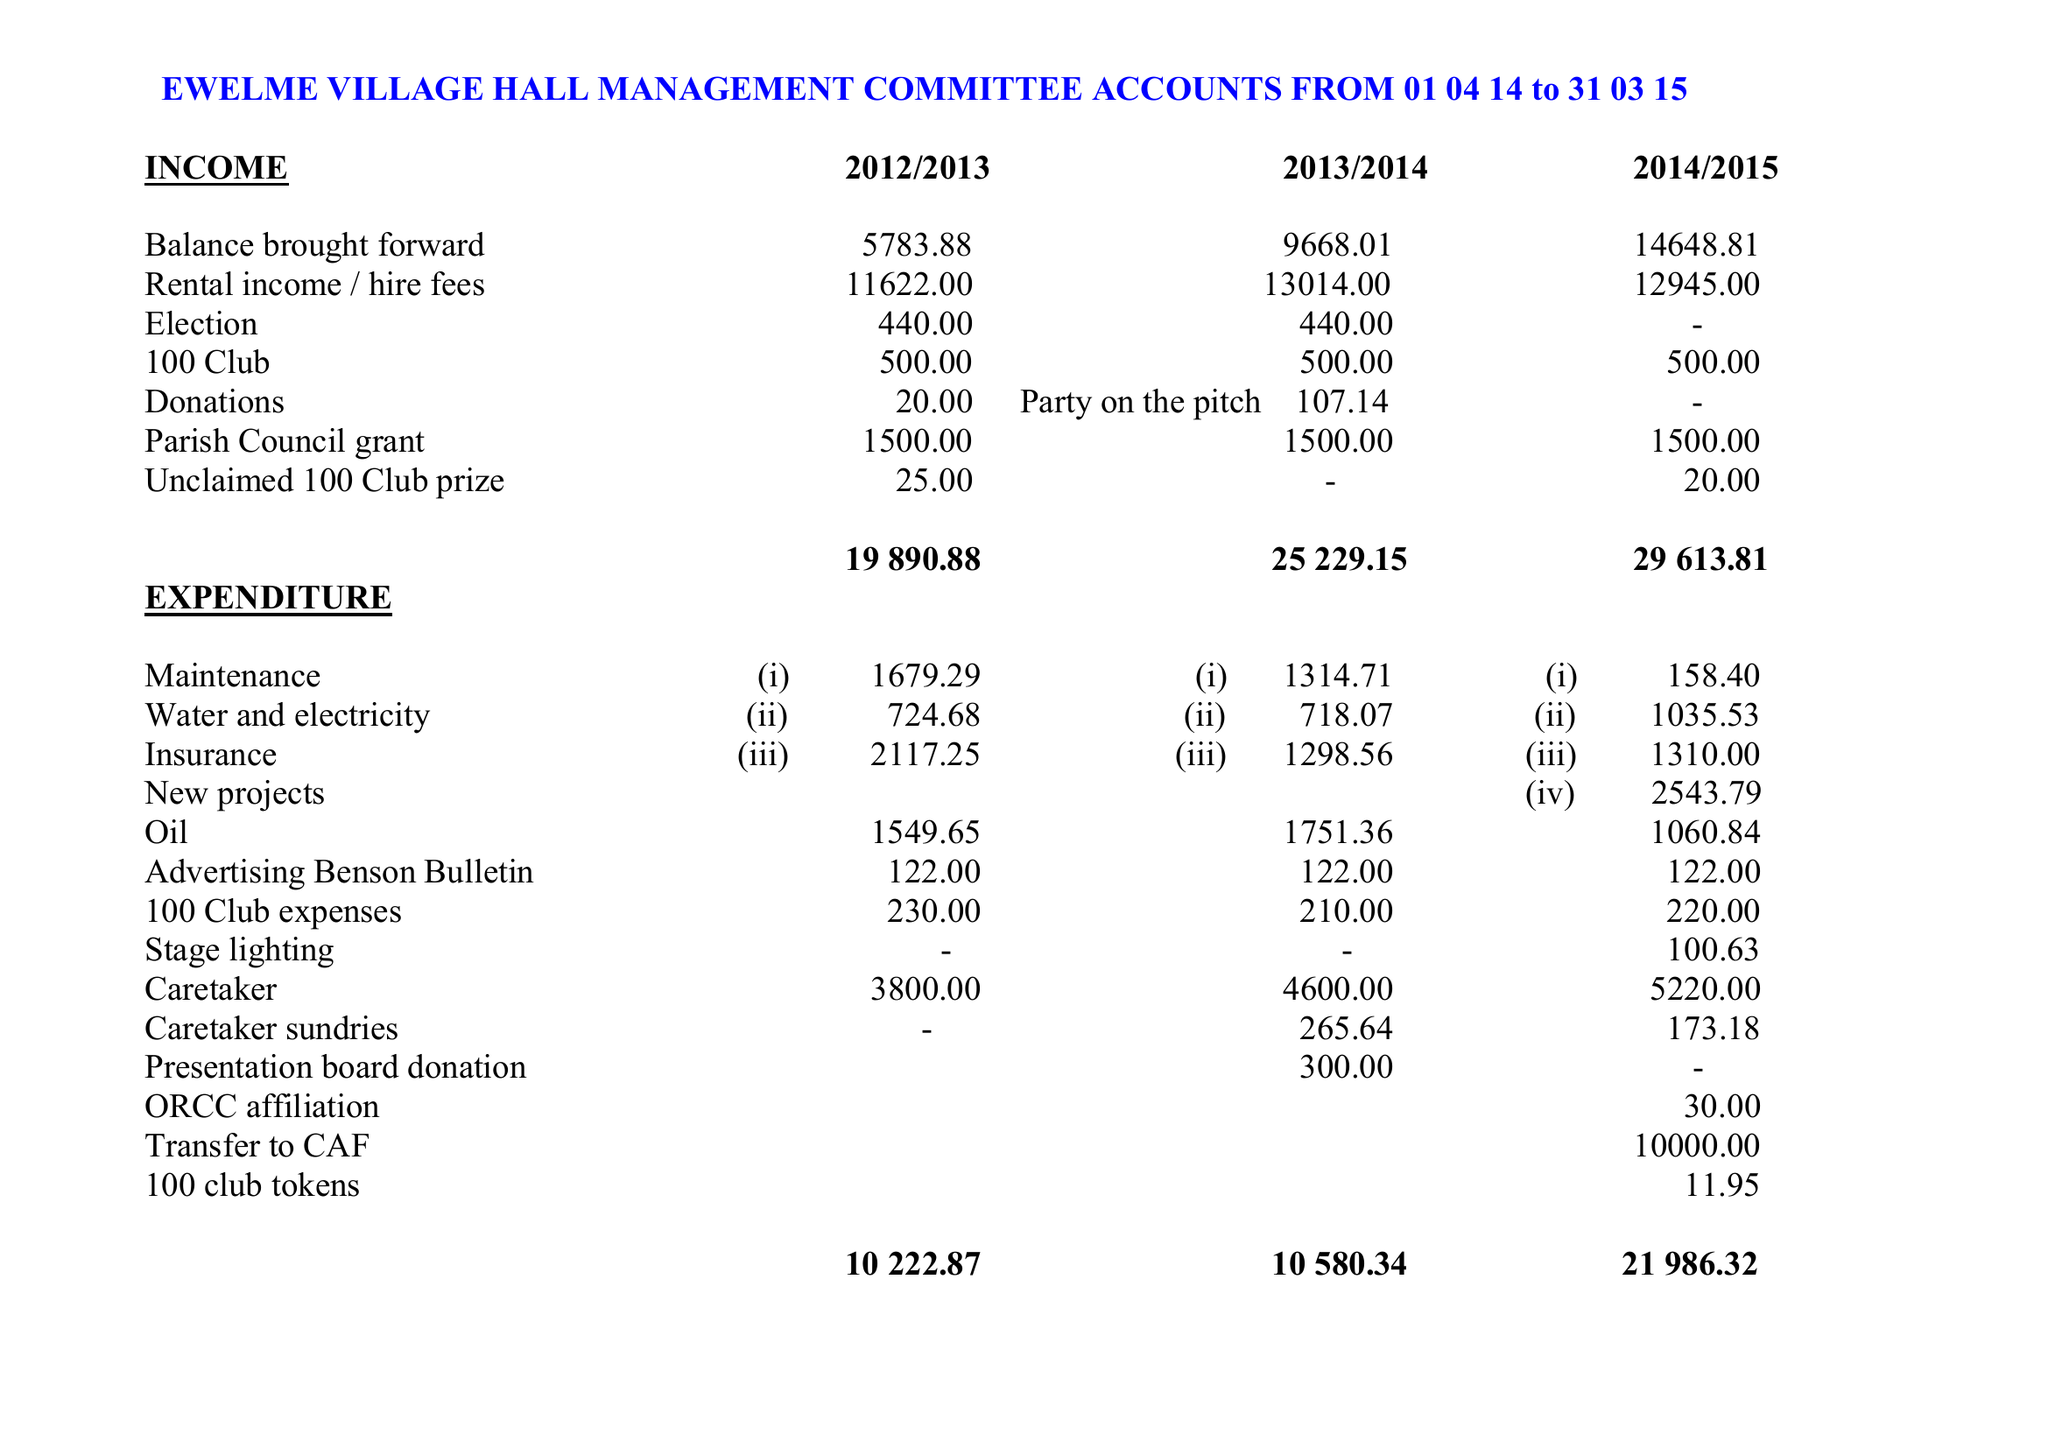What is the value for the charity_number?
Answer the question using a single word or phrase. 231997 